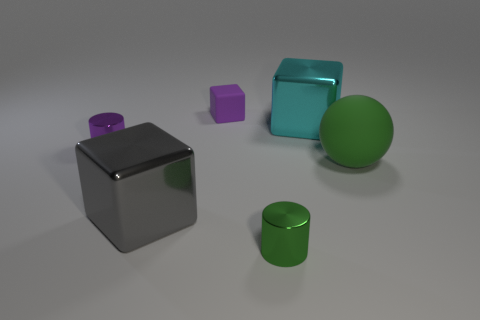Add 1 large purple balls. How many objects exist? 7 Subtract all cylinders. How many objects are left? 4 Subtract all big metallic things. Subtract all tiny matte blocks. How many objects are left? 3 Add 6 purple rubber objects. How many purple rubber objects are left? 7 Add 2 cyan objects. How many cyan objects exist? 3 Subtract 0 gray balls. How many objects are left? 6 